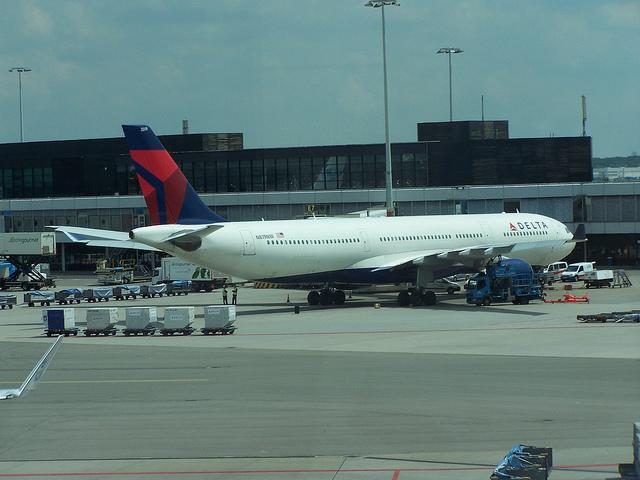Which country does this aircraft brand originate from? Please explain your reasoning. america. Its from the usa 